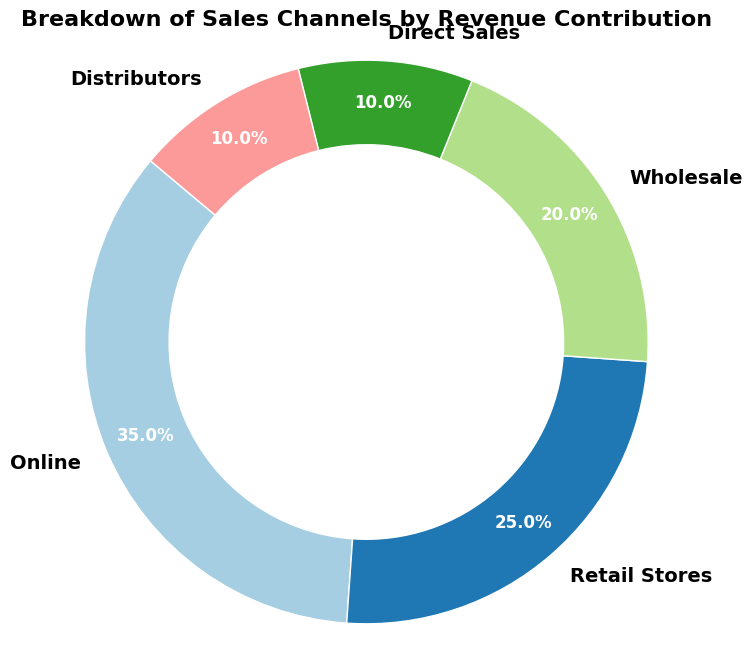What percentage of the total revenue is contributed by Distributors and Direct Sales combined? To find the combined percentage, add the revenue contribution of Distributors (10%) and Direct Sales (10%). The sum is 10% + 10% = 20%.
Answer: 20% Which channel contributes the most to the revenue? Compare the revenue contributions of all channels. The Online channel has the largest slice at 35%.
Answer: Online Out of Retail Stores and Wholesale, which channel has a lower revenue contribution? Compare the percentage contributions of Retail Stores (25%) and Wholesale (20%). Retail Stores contributes more, so Wholesale contributes less.
Answer: Wholesale What is the difference in revenue contribution between the highest and the lowest contributing channels? The highest contribution is from Online (35%) and the lowest contributions are from Direct Sales and Distributors (10% each). Difference is 35% - 10% = 25%.
Answer: 25% Which channel contributions are equal in terms of revenue percentage? Compare the revenue contributions of all channels. Direct Sales and Distributors both contribute 10%.
Answer: Direct Sales and Distributors Arrange the channels in descending order of their revenue contribution percentages. List the channels by their contributions: Online (35%), Retail Stores (25%), Wholesale (20%), Direct Sales (10%), Distributors (10%).
Answer: Online, Retail Stores, Wholesale, Direct Sales, Distributors What is the combined revenue contribution of the three least contributing channels? Add the contributions of Wholesale (20%), Direct Sales (10%), and Distributors (10%). The sum is 20% + 10% + 10% = 40%.
Answer: 40% If the combined revenue from Direct Sales and Distributors doubled, what would be the new percentage contribution for these two channels together? The current combined contribution is 20%. If it doubles, the new contribution will be 20% * 2 = 40%.
Answer: 40% Which channel's slice of the chart is light green in color? Identify the slice colored light green, which corresponds to Retail Stores.
Answer: Retail Stores What is the third largest revenue contribution channel? Arrange channels by contributions: 1st - Online (35%), 2nd - Retail Stores (25%), 3rd - Wholesale (20%).
Answer: Wholesale 